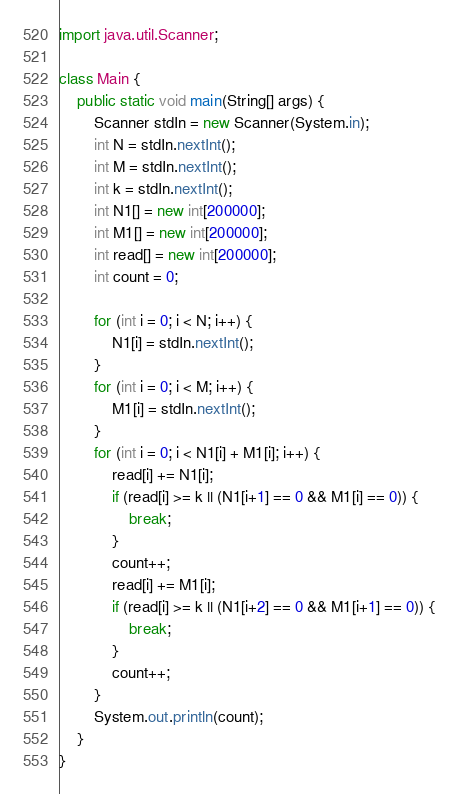<code> <loc_0><loc_0><loc_500><loc_500><_Java_>import java.util.Scanner;

class Main {
    public static void main(String[] args) {
        Scanner stdIn = new Scanner(System.in);
        int N = stdIn.nextInt();
        int M = stdIn.nextInt();
        int k = stdIn.nextInt();
        int N1[] = new int[200000];
        int M1[] = new int[200000];
        int read[] = new int[200000];
        int count = 0;

        for (int i = 0; i < N; i++) {
            N1[i] = stdIn.nextInt();
        }
        for (int i = 0; i < M; i++) {
            M1[i] = stdIn.nextInt();
        }
        for (int i = 0; i < N1[i] + M1[i]; i++) {           
            read[i] += N1[i];
            if (read[i] >= k || (N1[i+1] == 0 && M1[i] == 0)) {
                break;
            }
            count++;
            read[i] += M1[i];
            if (read[i] >= k || (N1[i+2] == 0 && M1[i+1] == 0)) {
                break;
            }
            count++;
        }
        System.out.println(count);
    }
}</code> 